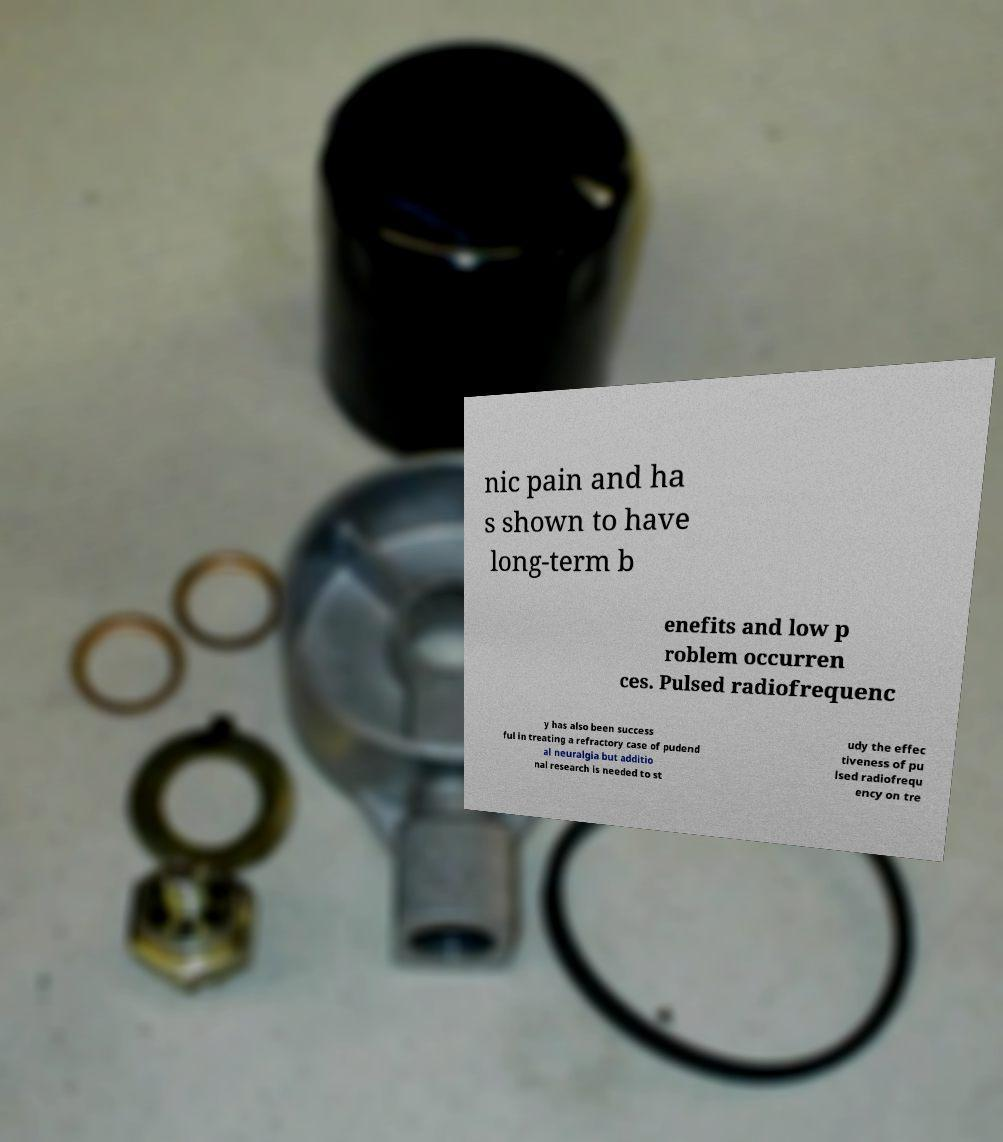I need the written content from this picture converted into text. Can you do that? nic pain and ha s shown to have long-term b enefits and low p roblem occurren ces. Pulsed radiofrequenc y has also been success ful in treating a refractory case of pudend al neuralgia but additio nal research is needed to st udy the effec tiveness of pu lsed radiofrequ ency on tre 